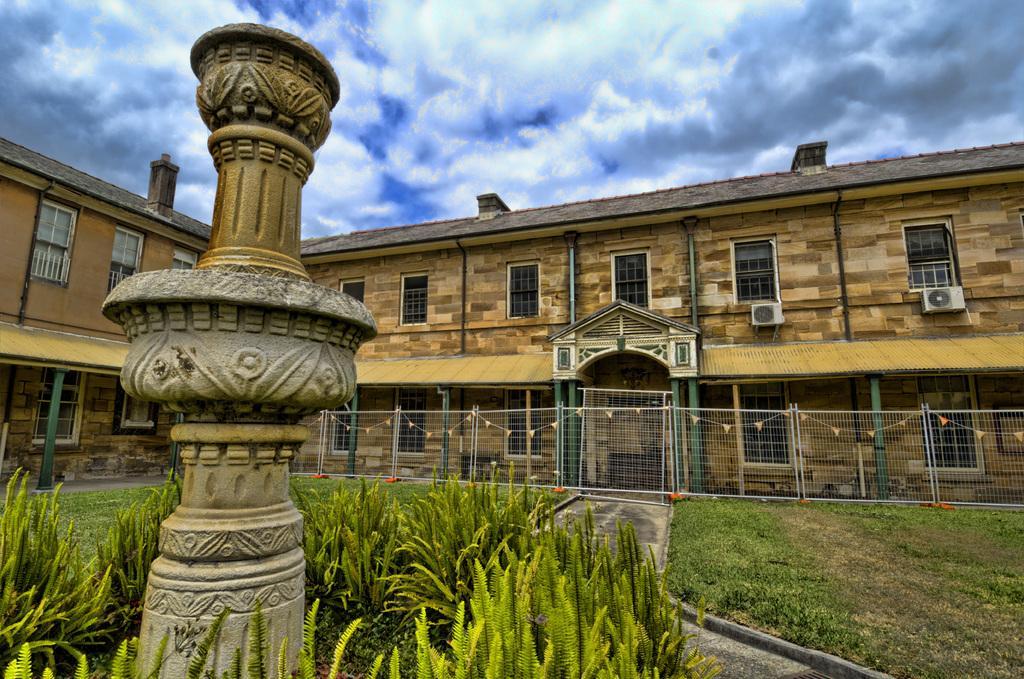Can you describe this image briefly? In this image there is a monument in the bottom of this image and there are some plants are around to this monument. There is a fencing wall in middle of this image and there is a building is behind to this fencing wall. There is a cloudy sky on the top of this image. 